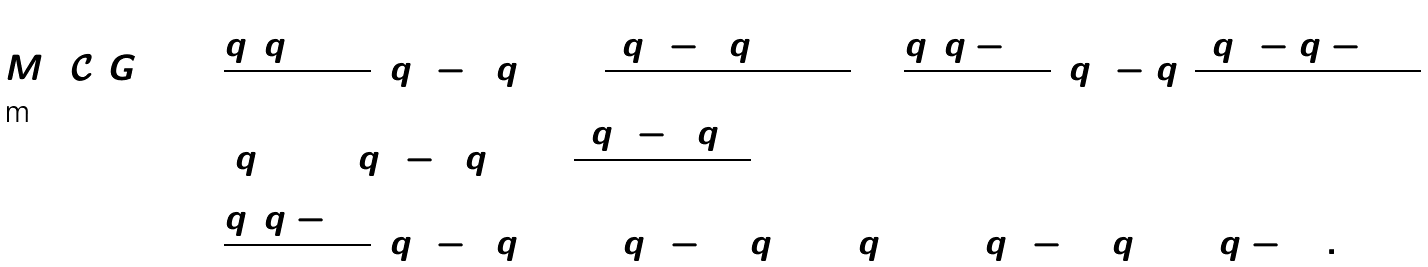<formula> <loc_0><loc_0><loc_500><loc_500>M _ { 2 } ( \mathcal { C } ( G ) ) & = \frac { q ( q + 1 ) } { 2 } ( q ^ { 2 } - 3 q + 2 ) \frac { ( q ^ { 2 } - 3 q + 1 ) ^ { 3 } } { 2 } + \frac { q ( q - 1 ) } { 2 } ( q ^ { 2 } - q ) \frac { ( q ^ { 2 } - q - 1 ) ^ { 3 } } { 2 } \\ & + ( q + 1 ) ( q ^ { 2 } - 2 q + 1 ) \frac { ( q ^ { 2 } - 2 q ) ^ { 3 } } { 2 } \\ & = \frac { q ( q - 1 ) } { 2 } ( q ^ { 8 } - 6 q ^ { 7 } + 1 4 q ^ { 6 } - 1 5 q ^ { 5 } + 3 q ^ { 4 } + 1 2 q ^ { 3 } - 1 6 q ^ { 2 } + 9 q - 1 ) .</formula> 